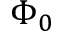<formula> <loc_0><loc_0><loc_500><loc_500>\Phi _ { 0 }</formula> 